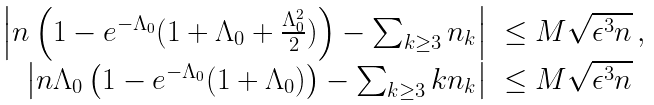Convert formula to latex. <formula><loc_0><loc_0><loc_500><loc_500>\begin{array} { r l } \left | n \left ( 1 - e ^ { - \Lambda _ { 0 } } ( 1 + \Lambda _ { 0 } + \frac { \Lambda _ { 0 } ^ { 2 } } 2 ) \right ) - \sum _ { k \geq 3 } n _ { k } \right | & \leq M \sqrt { \epsilon ^ { 3 } n } \, , \\ \left | n \Lambda _ { 0 } \left ( 1 - e ^ { - \Lambda _ { 0 } } ( 1 + \Lambda _ { 0 } ) \right ) - \sum _ { k \geq 3 } k n _ { k } \right | & \leq M \sqrt { \epsilon ^ { 3 } n } \, \end{array}</formula> 